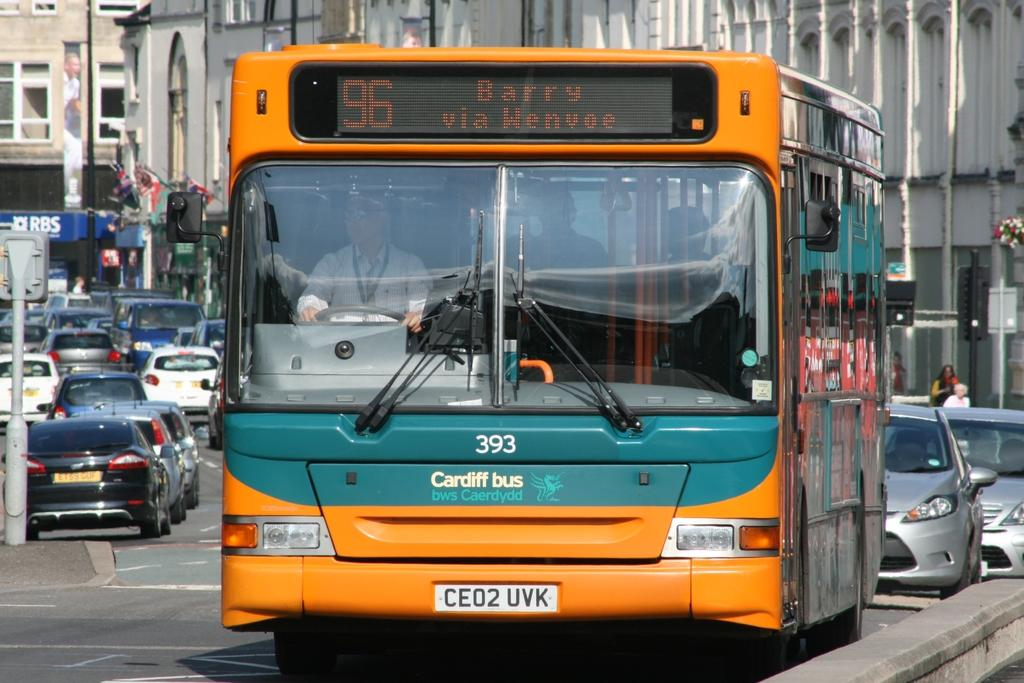What is the main subject in the foreground of the image? There is a bus in the foreground of the image. What else can be seen on the road in the foreground of the image? There are cars on the road in the foreground of the image. Where is the image taken? The image is taken on a road. What can be seen in the background of the image? There are buildings, boards, and windows in the background of the image. What type of marble is used for the buildings in the background of the image? There is no mention of marble in the image, as it focuses on a bus, cars, and the background elements. 